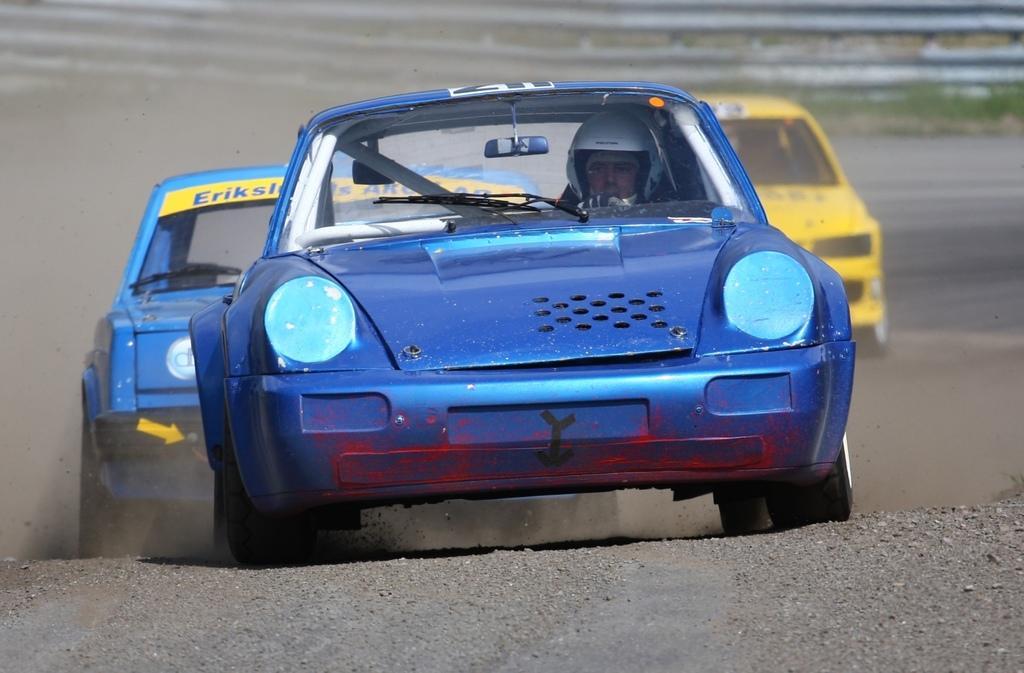Please provide a concise description of this image. In this picture we can see cars. In the background there is a fence. 